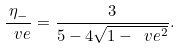<formula> <loc_0><loc_0><loc_500><loc_500>\frac { \eta _ { - } } { \ v e } = \frac { 3 } { 5 - 4 \sqrt { 1 - \ v e ^ { 2 } } } .</formula> 